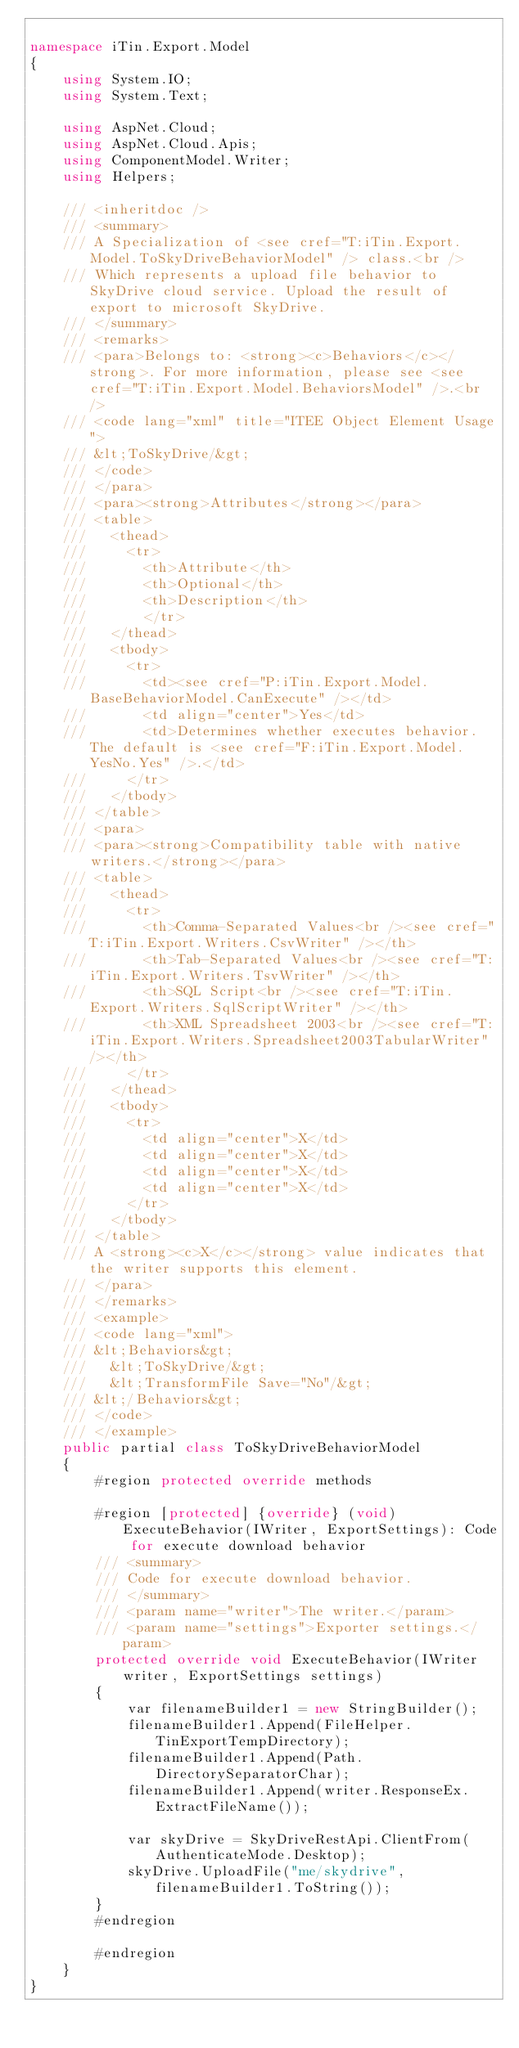<code> <loc_0><loc_0><loc_500><loc_500><_C#_>
namespace iTin.Export.Model
{
    using System.IO;
    using System.Text;

    using AspNet.Cloud;
    using AspNet.Cloud.Apis;
    using ComponentModel.Writer;
    using Helpers;

    /// <inheritdoc />
    /// <summary>
    /// A Specialization of <see cref="T:iTin.Export.Model.ToSkyDriveBehaviorModel" /> class.<br />
    /// Which represents a upload file behavior to SkyDrive cloud service. Upload the result of export to microsoft SkyDrive.
    /// </summary>
    /// <remarks>
    /// <para>Belongs to: <strong><c>Behaviors</c></strong>. For more information, please see <see cref="T:iTin.Export.Model.BehaviorsModel" />.<br />
    /// <code lang="xml" title="ITEE Object Element Usage">
    /// &lt;ToSkyDrive/&gt;
    /// </code>
    /// </para>
    /// <para><strong>Attributes</strong></para>
    /// <table>
    ///   <thead>
    ///     <tr>
    ///       <th>Attribute</th>
    ///       <th>Optional</th>
    ///       <th>Description</th>
    ///       </tr>
    ///   </thead>
    ///   <tbody>
    ///     <tr>
    ///       <td><see cref="P:iTin.Export.Model.BaseBehaviorModel.CanExecute" /></td>
    ///       <td align="center">Yes</td>
    ///       <td>Determines whether executes behavior. The default is <see cref="F:iTin.Export.Model.YesNo.Yes" />.</td>
    ///     </tr>
    ///   </tbody>
    /// </table>
    /// <para>
    /// <para><strong>Compatibility table with native writers.</strong></para>
    /// <table>
    ///   <thead>
    ///     <tr>
    ///       <th>Comma-Separated Values<br /><see cref="T:iTin.Export.Writers.CsvWriter" /></th>
    ///       <th>Tab-Separated Values<br /><see cref="T:iTin.Export.Writers.TsvWriter" /></th>
    ///       <th>SQL Script<br /><see cref="T:iTin.Export.Writers.SqlScriptWriter" /></th>
    ///       <th>XML Spreadsheet 2003<br /><see cref="T:iTin.Export.Writers.Spreadsheet2003TabularWriter" /></th>
    ///     </tr>
    ///   </thead>
    ///   <tbody>
    ///     <tr>
    ///       <td align="center">X</td>
    ///       <td align="center">X</td>
    ///       <td align="center">X</td>
    ///       <td align="center">X</td>
    ///     </tr>
    ///   </tbody>
    /// </table>
    /// A <strong><c>X</c></strong> value indicates that the writer supports this element.
    /// </para>
    /// </remarks>
    /// <example>
    /// <code lang="xml">
    /// &lt;Behaviors&gt;
    ///   &lt;ToSkyDrive/&gt;
    ///   &lt;TransformFile Save="No"/&gt;
    /// &lt;/Behaviors&gt;
    /// </code>
    /// </example>
    public partial class ToSkyDriveBehaviorModel
    {
        #region protected override methods

        #region [protected] {override} (void) ExecuteBehavior(IWriter, ExportSettings): Code for execute download behavior
        /// <summary>
        /// Code for execute download behavior.
        /// </summary>
        /// <param name="writer">The writer.</param>
        /// <param name="settings">Exporter settings.</param>
        protected override void ExecuteBehavior(IWriter writer, ExportSettings settings)
        {
            var filenameBuilder1 = new StringBuilder();
            filenameBuilder1.Append(FileHelper.TinExportTempDirectory);
            filenameBuilder1.Append(Path.DirectorySeparatorChar);
            filenameBuilder1.Append(writer.ResponseEx.ExtractFileName());

            var skyDrive = SkyDriveRestApi.ClientFrom(AuthenticateMode.Desktop);
            skyDrive.UploadFile("me/skydrive", filenameBuilder1.ToString());
        }
        #endregion

        #endregion
    }
}
</code> 